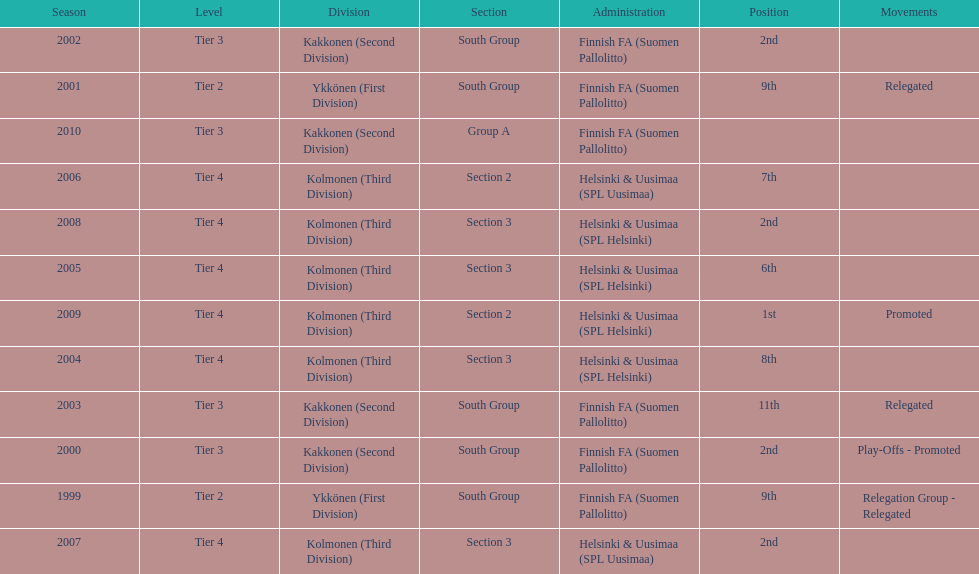How many consecutive times did they play in tier 4? 6. 